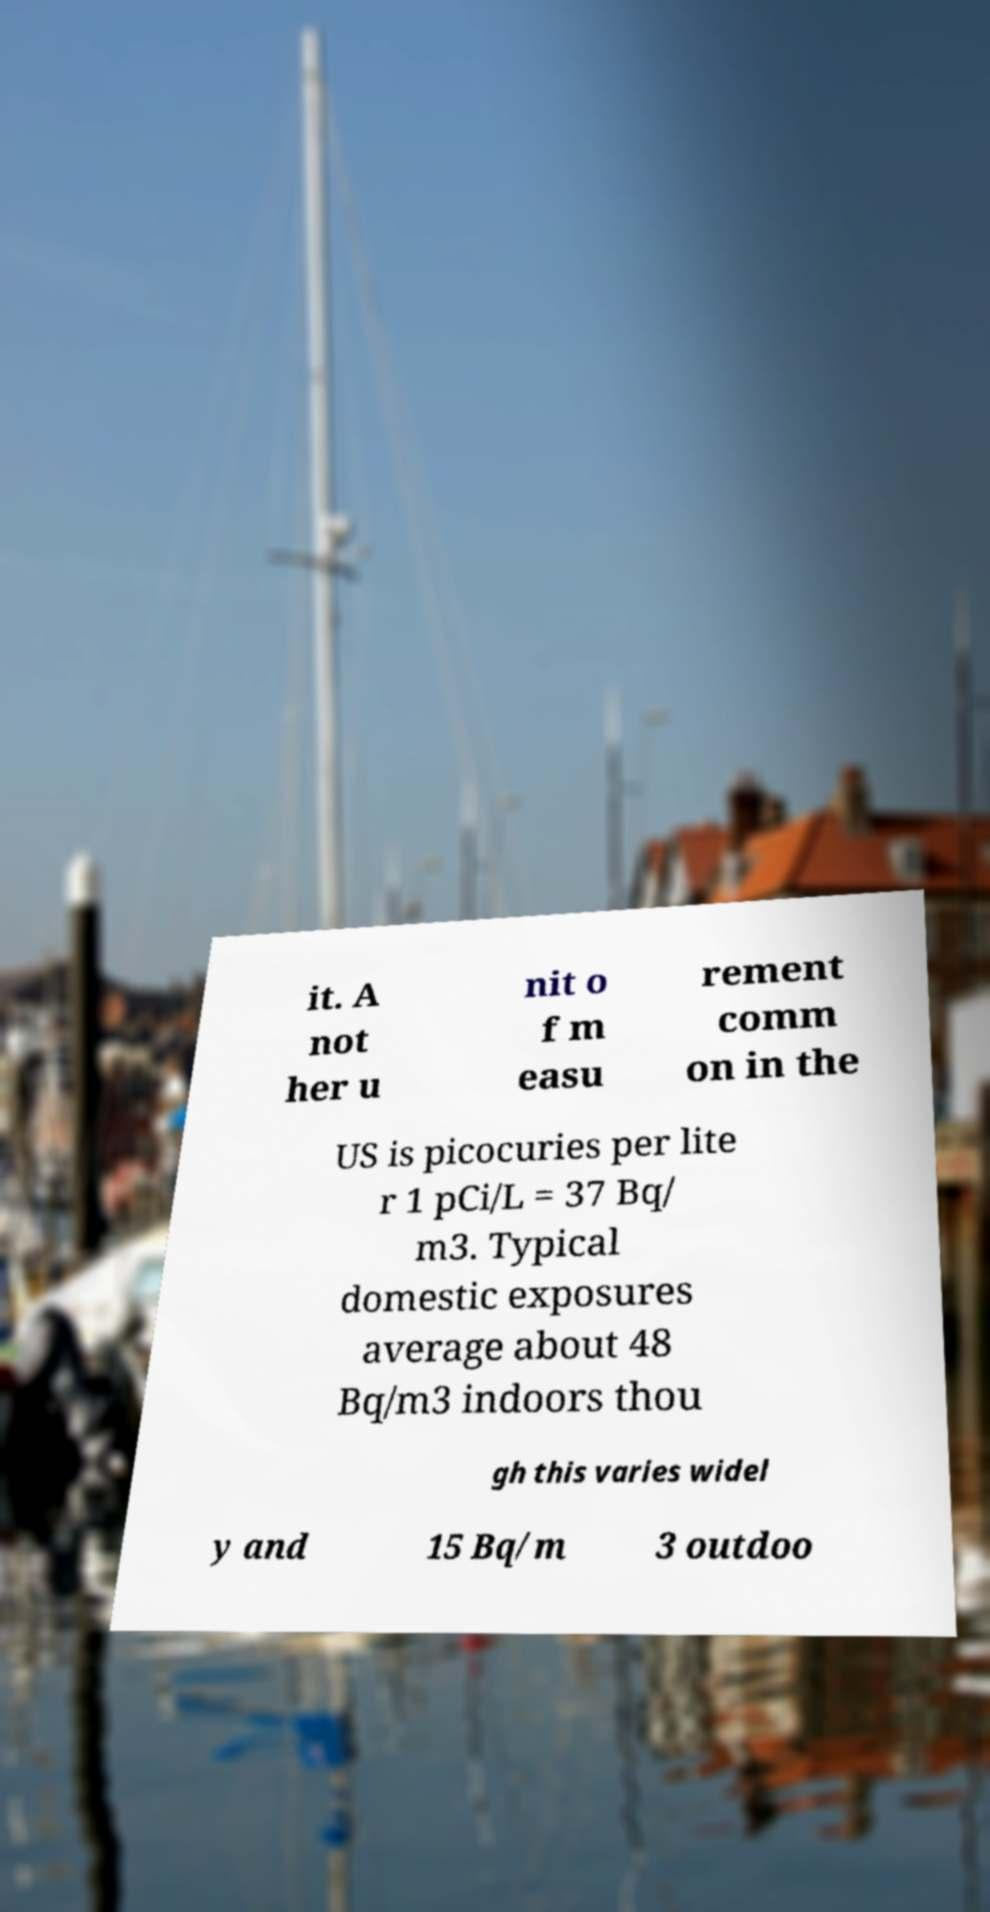There's text embedded in this image that I need extracted. Can you transcribe it verbatim? it. A not her u nit o f m easu rement comm on in the US is picocuries per lite r 1 pCi/L = 37 Bq/ m3. Typical domestic exposures average about 48 Bq/m3 indoors thou gh this varies widel y and 15 Bq/m 3 outdoo 